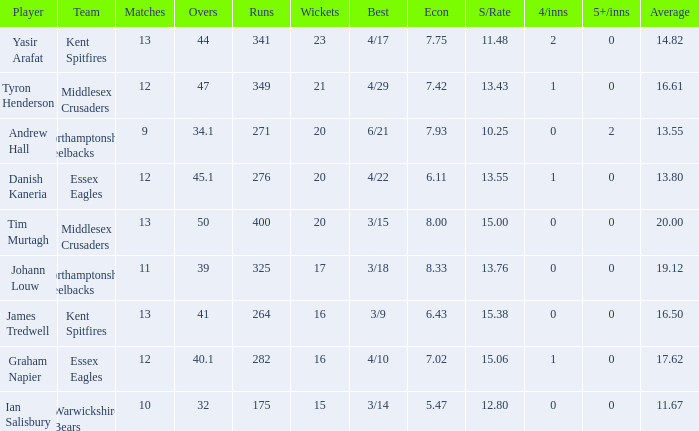Name the least matches for runs being 276 12.0. 